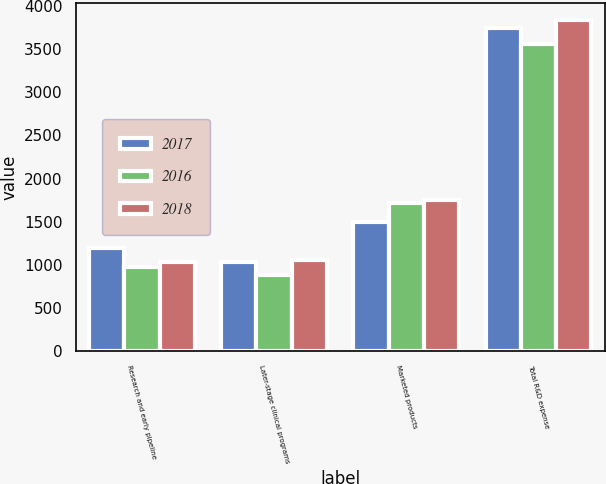Convert chart. <chart><loc_0><loc_0><loc_500><loc_500><stacked_bar_chart><ecel><fcel>Research and early pipeline<fcel>Later-stage clinical programs<fcel>Marketed products<fcel>Total R&D expense<nl><fcel>2017<fcel>1201<fcel>1034<fcel>1502<fcel>3737<nl><fcel>2016<fcel>972<fcel>879<fcel>1711<fcel>3562<nl><fcel>2018<fcel>1039<fcel>1054<fcel>1747<fcel>3840<nl></chart> 